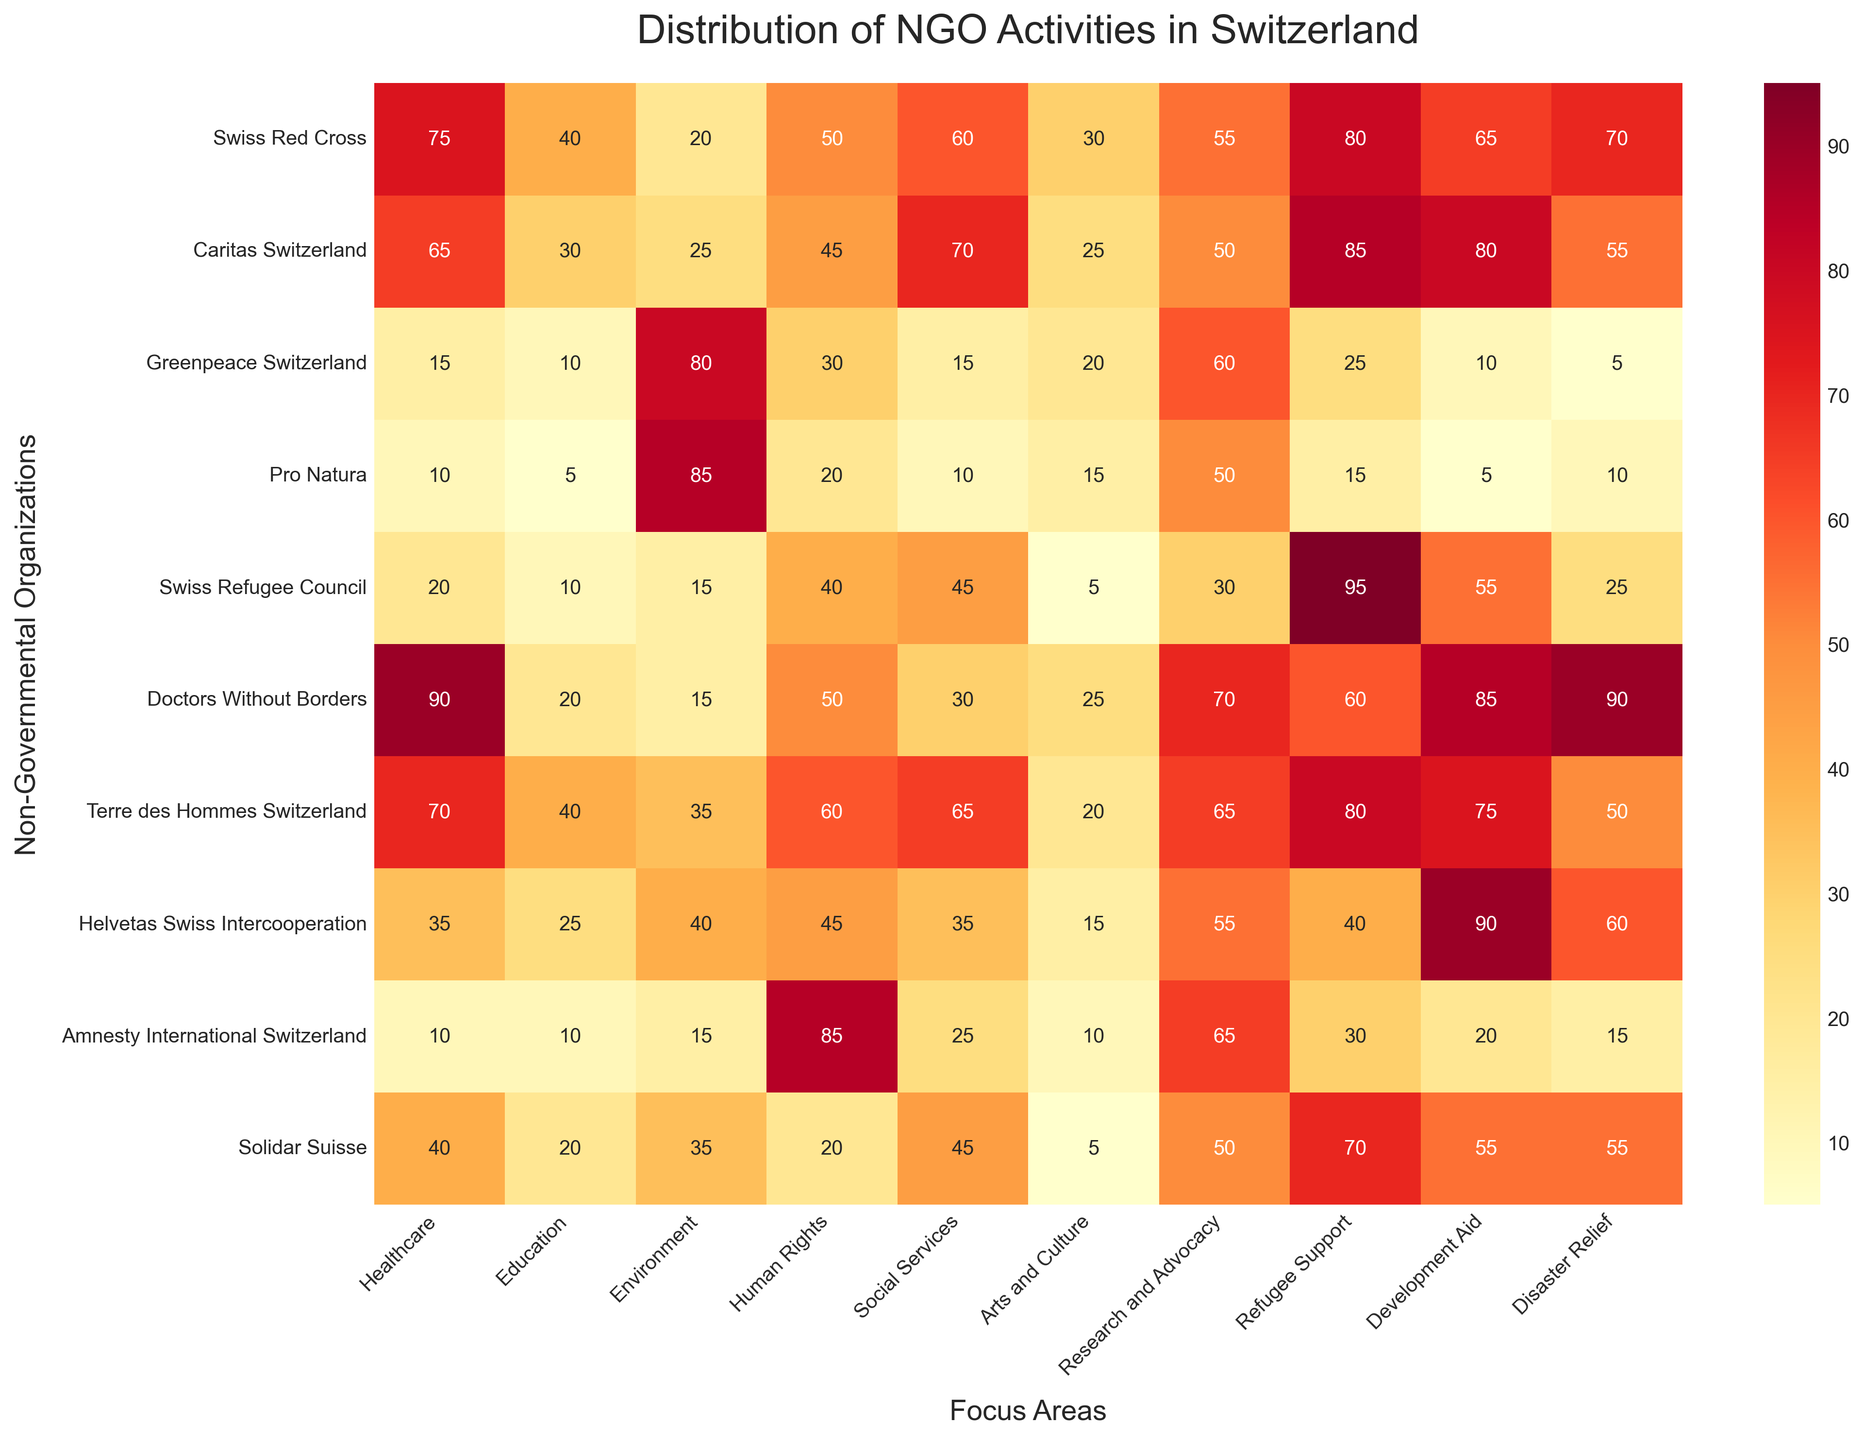Which NGO has the highest activity level in Healthcare? Looking at the 'Healthcare' column, find the highest value, which is 90, and check the corresponding NGO. This value corresponds to Doctors Without Borders.
Answer: Doctors Without Borders How many focus areas have a perfect score (85) for Pro Natura? Look at the row corresponding to Pro Natura and count the number of focus areas with a value of 85.
Answer: 1 Which NGO has the most balanced activity distribution (smallest difference between highest and lowest activity level)? Calculate the difference between the highest and lowest values for each NGO's row and identify the NGO with the smallest difference.
Answer: Terre des Hommes Switzerland What is the average activity level in Environment focus area? Sum the values in the 'Environment' column (20 + 25 + 80 + 85 + 15 + 15 + 35 + 40 + 15 + 35 = 365) and divide by the number of NGOs (10).
Answer: 36.5 Which focus area has the lowest activity level overall and what is it? Sum the values in each focus area column and identify the one with the lowest sum. "Arts and Culture" has the lowest sum, which is 55 + 50 + 60 + 50 + 30 + 70 + 65 + 55 + 65 + 50 = 550, which is the lowest.
Answer: Arts and Culture, 550 Between Suisse Red Cross and Caritas Switzerland, which NGO is more involved in Development Aid? Compare the values in the 'Development Aid' column for Swiss Red Cross (70) and Caritas Switzerland (55).
Answer: Swiss Red Cross Which focus area does Greenpeace Switzerland score the highest in? Look at the row corresponding to Greenpeace Switzerland and find the highest value, which is 80, in the 'Environment' column.
Answer: Environment How many NGOs are more focused on Refugee Support than on Social Services? Compare the values in the 'Refugee Support' and 'Social Services' columns for each NGO. NGOs with higher values in 'Refugee Support' are Swiss Red Cross, Caritas Switzerland, Swiss Refugee Council, Doctors Without Borders, Terre des Hommes Switzerland, Helvetas Swiss Intercooperation, and Solidar Suisse. This sums up to 7 NGOs.
Answer: 7 Which NGO has the highest involvement in Human Rights? Look at the 'Human Rights' column and identify the highest value, 85, which corresponds to Amnesty International Switzerland.
Answer: Amnesty International Switzerland 